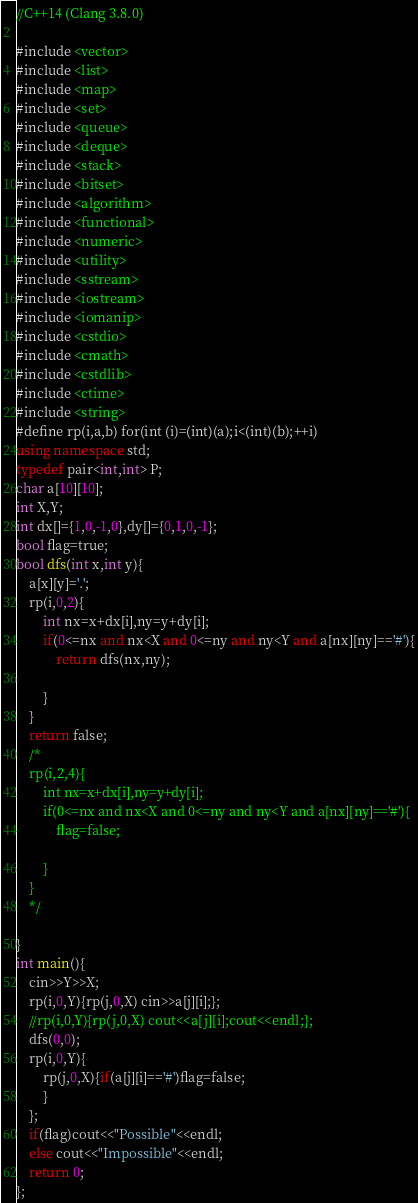Convert code to text. <code><loc_0><loc_0><loc_500><loc_500><_C++_>//C++14 (Clang 3.8.0)

#include <vector>
#include <list>
#include <map>
#include <set>
#include <queue>
#include <deque>
#include <stack>
#include <bitset>
#include <algorithm>
#include <functional>
#include <numeric>
#include <utility>
#include <sstream>
#include <iostream>
#include <iomanip>
#include <cstdio>
#include <cmath>
#include <cstdlib>
#include <ctime>
#include <string>
#define rp(i,a,b) for(int (i)=(int)(a);i<(int)(b);++i)
using namespace std;
typedef pair<int,int> P;
char a[10][10];
int X,Y;
int dx[]={1,0,-1,0},dy[]={0,1,0,-1};
bool flag=true;
bool dfs(int x,int y){
    a[x][y]='.';
    rp(i,0,2){
        int nx=x+dx[i],ny=y+dy[i];
        if(0<=nx and nx<X and 0<=ny and ny<Y and a[nx][ny]=='#'){
            return dfs(nx,ny);

        }
    }
    return false;
    /*
    rp(i,2,4){
        int nx=x+dx[i],ny=y+dy[i];
        if(0<=nx and nx<X and 0<=ny and ny<Y and a[nx][ny]=='#'){
            flag=false;

        }
    }
    */
        
}
int main(){
    cin>>Y>>X;
    rp(i,0,Y){rp(j,0,X) cin>>a[j][i];};
    //rp(i,0,Y){rp(j,0,X) cout<<a[j][i];cout<<endl;};
    dfs(0,0);
    rp(i,0,Y){
        rp(j,0,X){if(a[j][i]=='#')flag=false;
        } 
    };
    if(flag)cout<<"Possible"<<endl;
    else cout<<"Impossible"<<endl;
    return 0;
};
</code> 